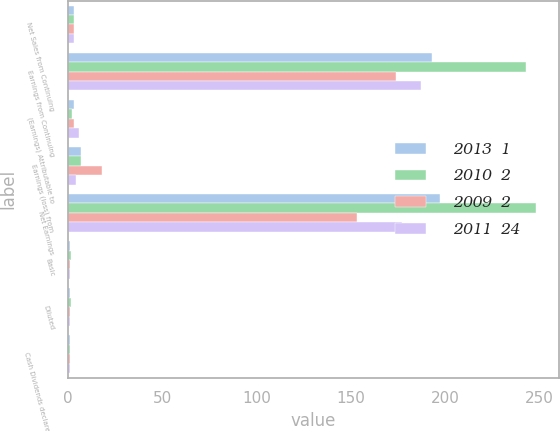Convert chart. <chart><loc_0><loc_0><loc_500><loc_500><stacked_bar_chart><ecel><fcel>Net Sales from Continuing<fcel>Earnings from Continuing<fcel>(Earnings) Attributable to<fcel>Earnings (loss) from<fcel>Net Earnings<fcel>Basic<fcel>Diluted<fcel>Cash Dividends declared per<nl><fcel>2013  1<fcel>3<fcel>193<fcel>3<fcel>7<fcel>197<fcel>1.31<fcel>1.29<fcel>1.18<nl><fcel>2010  2<fcel>3<fcel>243<fcel>2<fcel>7<fcel>248<fcel>1.67<fcel>1.65<fcel>1.14<nl><fcel>2009  2<fcel>3<fcel>174<fcel>3<fcel>18<fcel>153<fcel>1.17<fcel>1.16<fcel>1.1<nl><fcel>2011  24<fcel>3<fcel>187<fcel>6<fcel>4<fcel>177<fcel>1.2<fcel>1.18<fcel>1.06<nl></chart> 